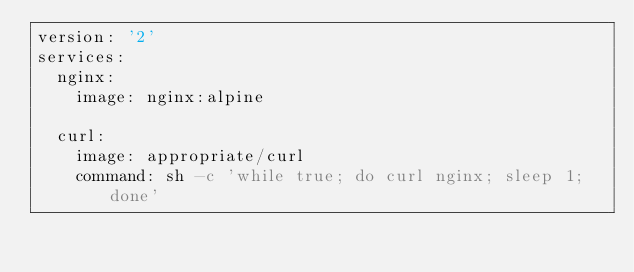<code> <loc_0><loc_0><loc_500><loc_500><_YAML_>version: '2'
services:
  nginx:
    image: nginx:alpine

  curl:
    image: appropriate/curl
    command: sh -c 'while true; do curl nginx; sleep 1; done'</code> 